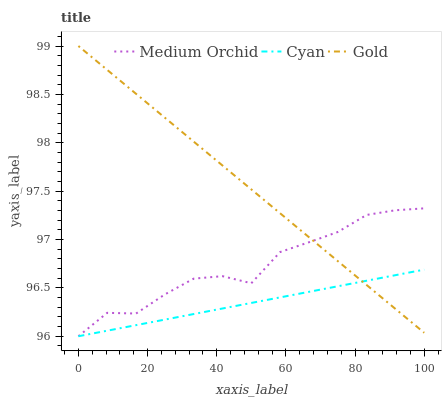Does Cyan have the minimum area under the curve?
Answer yes or no. Yes. Does Gold have the maximum area under the curve?
Answer yes or no. Yes. Does Medium Orchid have the minimum area under the curve?
Answer yes or no. No. Does Medium Orchid have the maximum area under the curve?
Answer yes or no. No. Is Gold the smoothest?
Answer yes or no. Yes. Is Medium Orchid the roughest?
Answer yes or no. Yes. Is Medium Orchid the smoothest?
Answer yes or no. No. Is Gold the roughest?
Answer yes or no. No. Does Cyan have the lowest value?
Answer yes or no. Yes. Does Gold have the lowest value?
Answer yes or no. No. Does Gold have the highest value?
Answer yes or no. Yes. Does Medium Orchid have the highest value?
Answer yes or no. No. Does Cyan intersect Gold?
Answer yes or no. Yes. Is Cyan less than Gold?
Answer yes or no. No. Is Cyan greater than Gold?
Answer yes or no. No. 